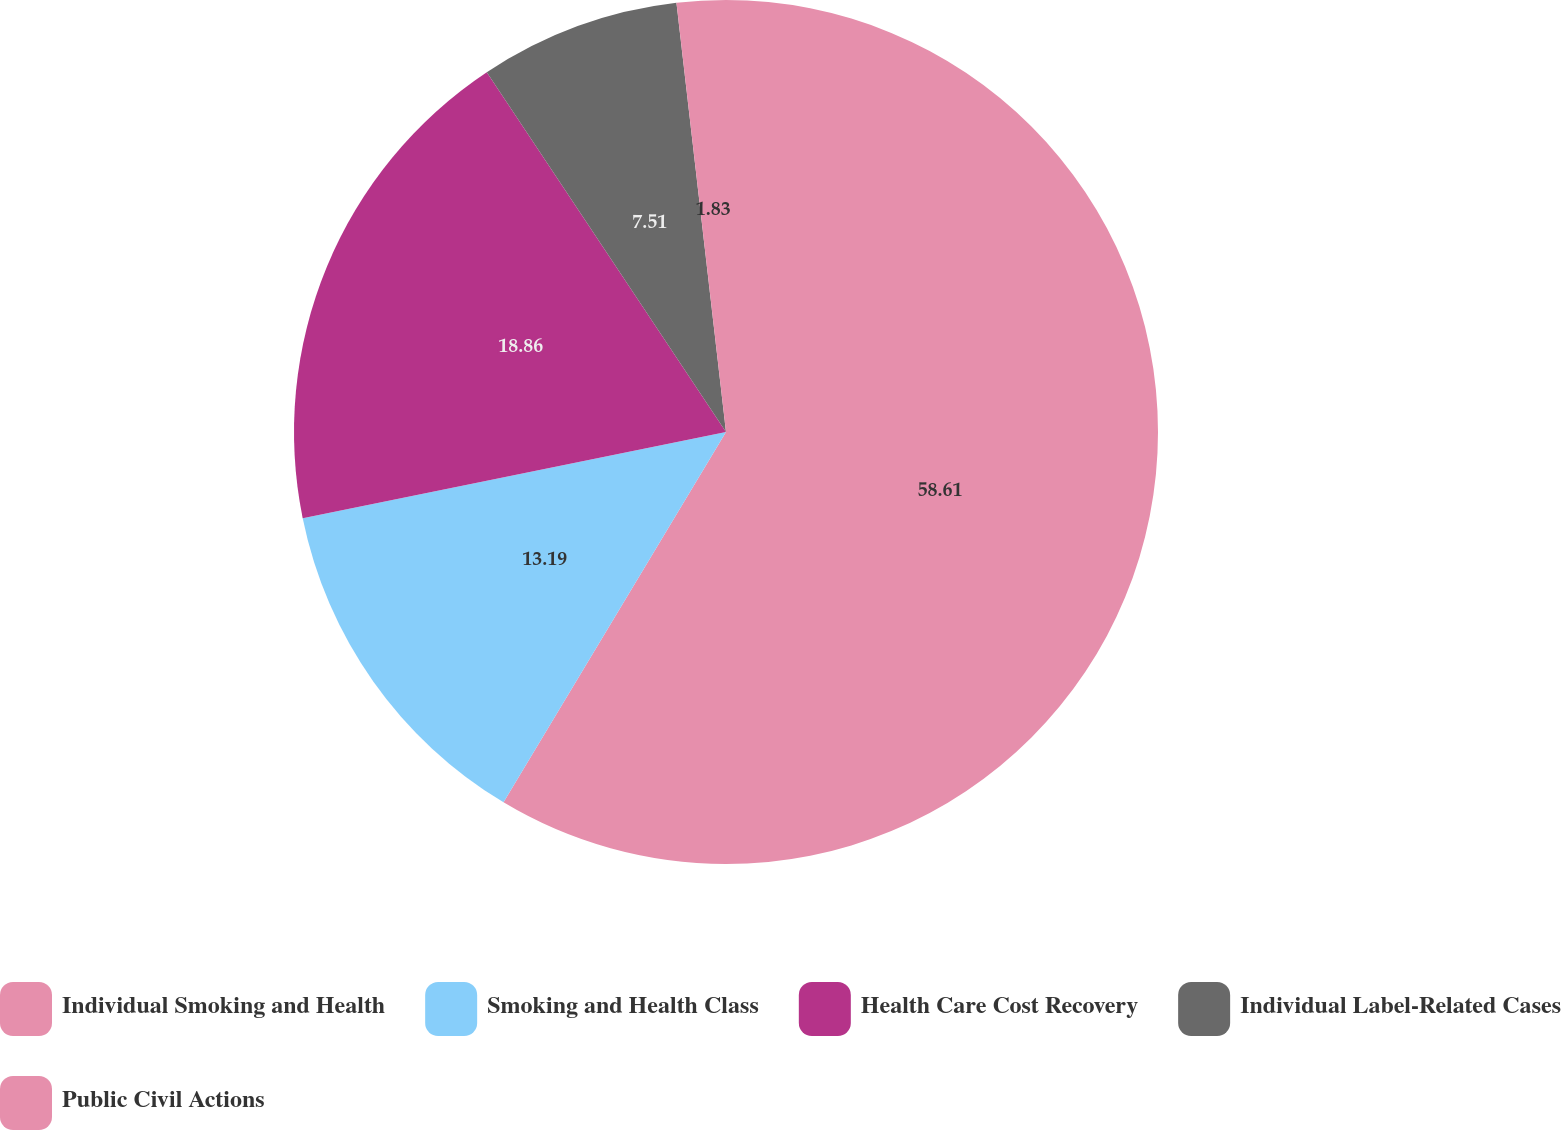Convert chart to OTSL. <chart><loc_0><loc_0><loc_500><loc_500><pie_chart><fcel>Individual Smoking and Health<fcel>Smoking and Health Class<fcel>Health Care Cost Recovery<fcel>Individual Label-Related Cases<fcel>Public Civil Actions<nl><fcel>58.61%<fcel>13.19%<fcel>18.86%<fcel>7.51%<fcel>1.83%<nl></chart> 